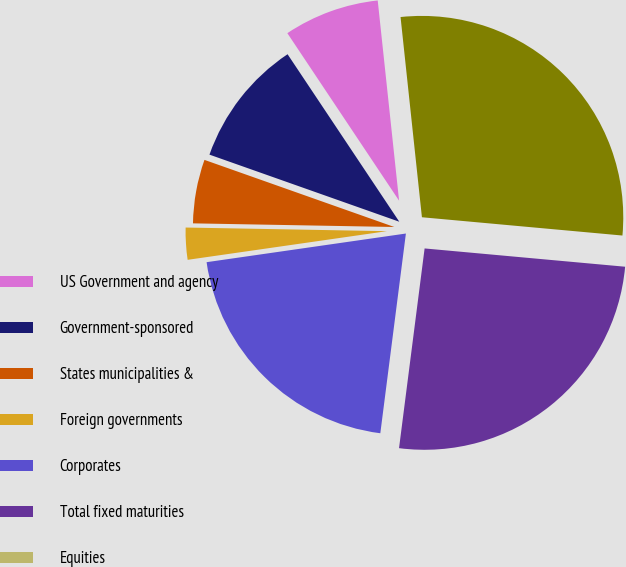Convert chart. <chart><loc_0><loc_0><loc_500><loc_500><pie_chart><fcel>US Government and agency<fcel>Government-sponsored<fcel>States municipalities &<fcel>Foreign governments<fcel>Corporates<fcel>Total fixed maturities<fcel>Equities<fcel>Total<nl><fcel>7.67%<fcel>10.23%<fcel>5.12%<fcel>2.56%<fcel>20.7%<fcel>25.58%<fcel>0.0%<fcel>28.14%<nl></chart> 